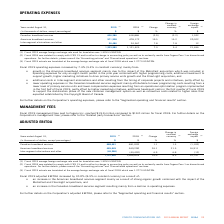According to Cogeco's financial document, What was the exchange rate in 2019? According to the financial document, 1.3255 USD/CDN.. The relevant text states: "age foreign exchange rate used for translation was 1.3255 USD/CDN...." Also, What was the exchange rate in 2018? According to the financial document, 1.2773 USD/CDN.. The relevant text states: "age foreign exchange rate of fiscal 2018 which was 1.2773 USD/CDN...." Also, What was the increase in 2019 operating expenses? According to the financial document, 7.3%. The relevant text states: "Fiscal 2019 operating expenses increased by 7.3% (5.4% in constant currency) mainly from:..." Also, can you calculate: What was the increase / (decrease) in Canadian broadband services from 2018 to 2019? Based on the calculation: 606,286 - 618,886, the result is -12600 (in thousands). This is based on the information: "Canadian broadband services 606,286 618,886 (2.0) (2.2) 1,102 Canadian broadband services 606,286 618,886 (2.0) (2.2) 1,102..." The key data points involved are: 606,286, 618,886. Also, can you calculate: What was the average American broadband services between 2018 and 2019? To answer this question, I need to perform calculations using the financial data. The calculation is: (571,208 + 478,172) / 2, which equals 524690 (in thousands). This is based on the information: "American broadband services 571,208 478,172 19.5 15.2 20,522 American broadband services 571,208 478,172 19.5 15.2 20,522..." The key data points involved are: 478,172, 571,208. Also, can you calculate: What was the increase / (decrease) in the Inter-segment eliminations and other from 2018 to 2019? Based on the calculation: 26,486 - 24,567, the result is 1919 (in thousands). This is based on the information: "Inter-segment eliminations and other 26,486 24,567 7.8 7.8 12 Inter-segment eliminations and other 26,486 24,567 7.8 7.8 12..." The key data points involved are: 24,567, 26,486. 